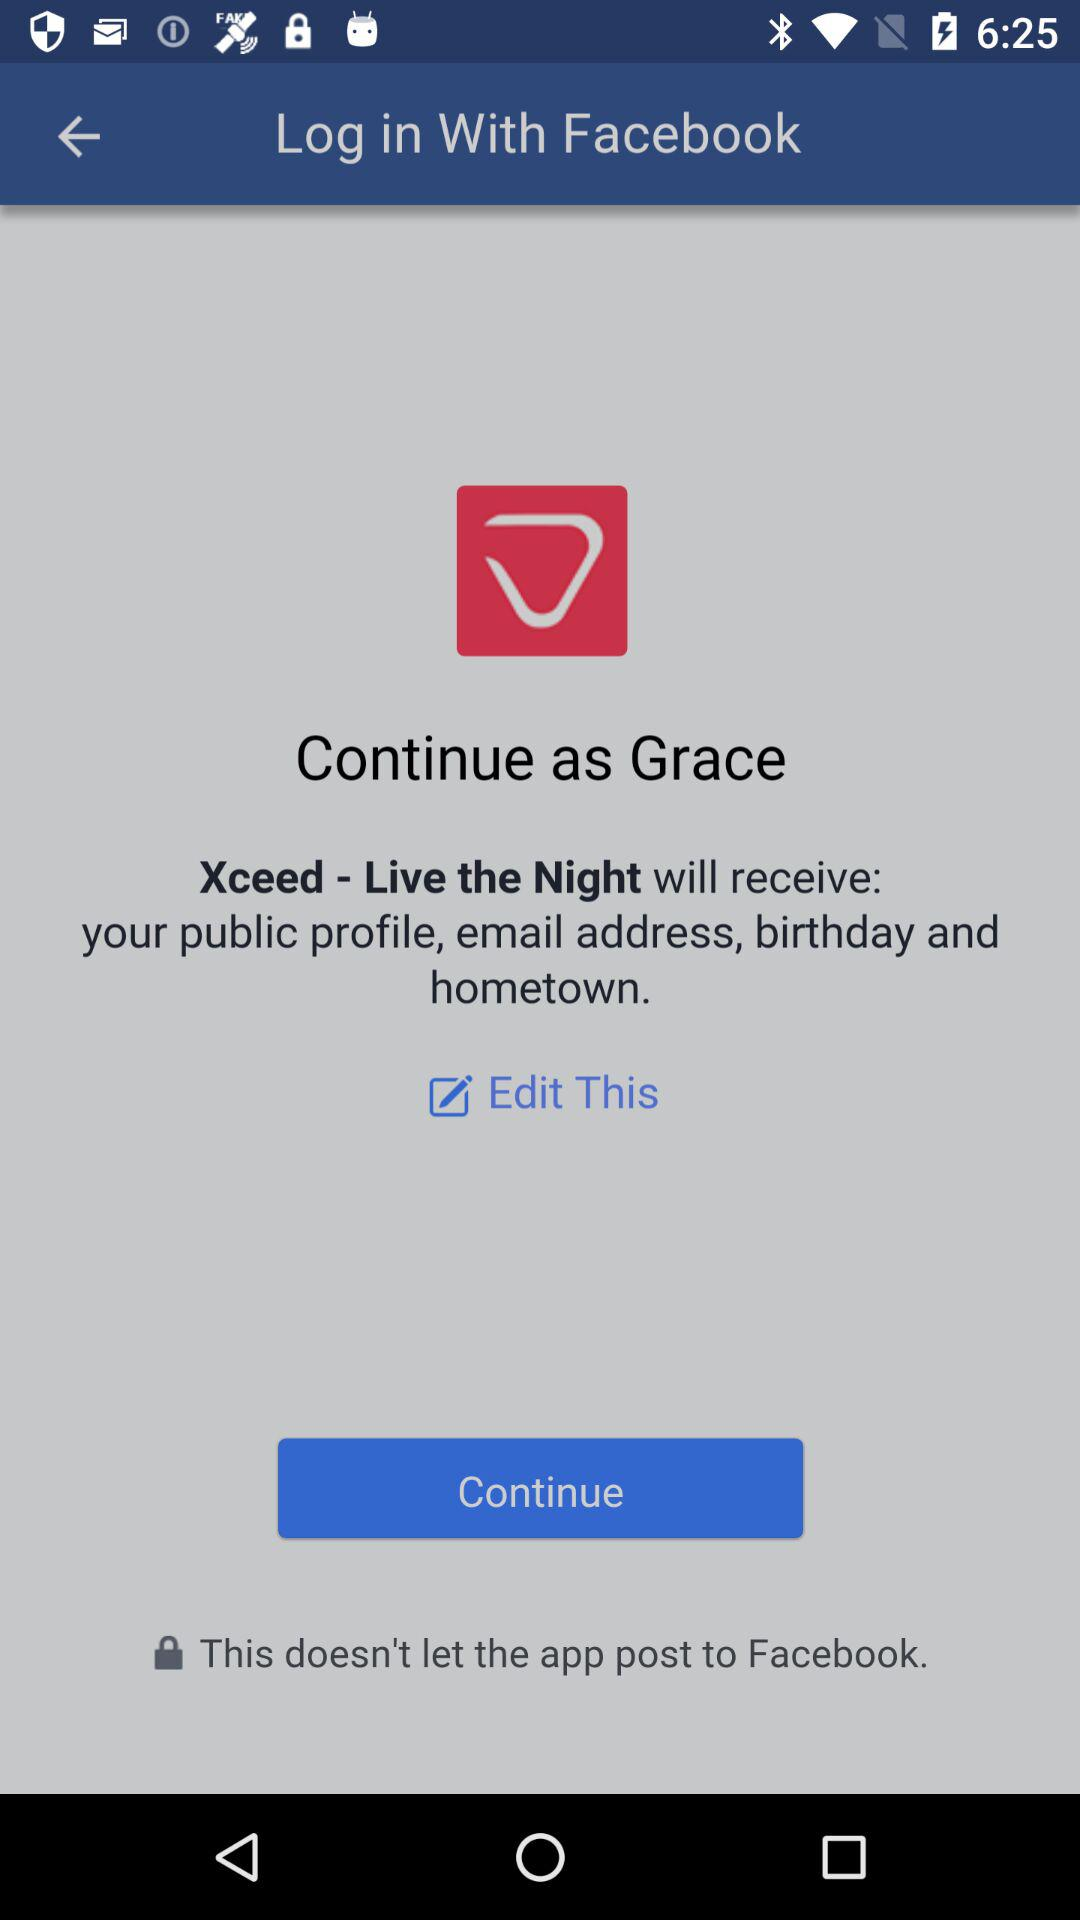What is Grace's last name?
When the provided information is insufficient, respond with <no answer>. <no answer> 